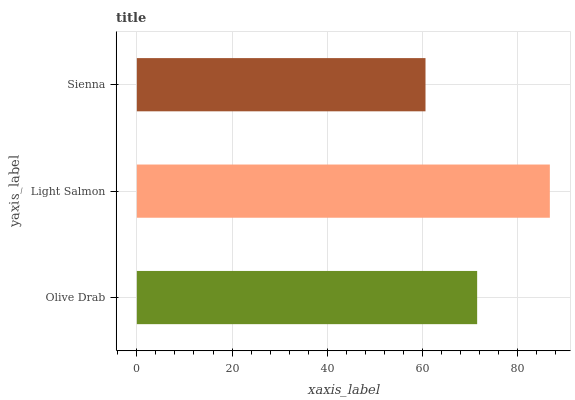Is Sienna the minimum?
Answer yes or no. Yes. Is Light Salmon the maximum?
Answer yes or no. Yes. Is Light Salmon the minimum?
Answer yes or no. No. Is Sienna the maximum?
Answer yes or no. No. Is Light Salmon greater than Sienna?
Answer yes or no. Yes. Is Sienna less than Light Salmon?
Answer yes or no. Yes. Is Sienna greater than Light Salmon?
Answer yes or no. No. Is Light Salmon less than Sienna?
Answer yes or no. No. Is Olive Drab the high median?
Answer yes or no. Yes. Is Olive Drab the low median?
Answer yes or no. Yes. Is Sienna the high median?
Answer yes or no. No. Is Light Salmon the low median?
Answer yes or no. No. 